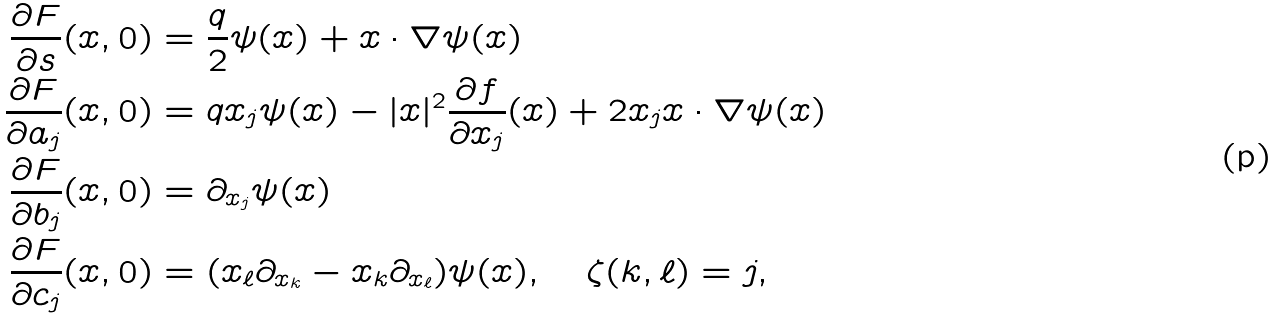Convert formula to latex. <formula><loc_0><loc_0><loc_500><loc_500>\frac { \partial F } { \partial s } ( x , 0 ) & = \frac { q } { 2 } \psi ( x ) + x \cdot \nabla \psi ( x ) \\ \frac { \partial F } { \partial a _ { j } } ( x , 0 ) & = q x _ { j } \psi ( x ) - | x | ^ { 2 } \frac { \partial f } { \partial x _ { j } } ( x ) + 2 x _ { j } x \cdot \nabla \psi ( x ) \\ \frac { \partial F } { \partial b _ { j } } ( x , 0 ) & = \partial _ { x _ { j } } \psi ( x ) \\ \frac { \partial F } { \partial c _ { j } } ( x , 0 ) & = ( x _ { \ell } \partial _ { x _ { k } } - x _ { k } \partial _ { x _ { \ell } } ) \psi ( x ) , \quad \zeta ( k , \ell ) = j ,</formula> 